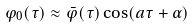Convert formula to latex. <formula><loc_0><loc_0><loc_500><loc_500>\varphi _ { 0 } ( \tau ) \approx { \bar { \varphi } } ( \tau ) \cos ( a \tau + \alpha )</formula> 